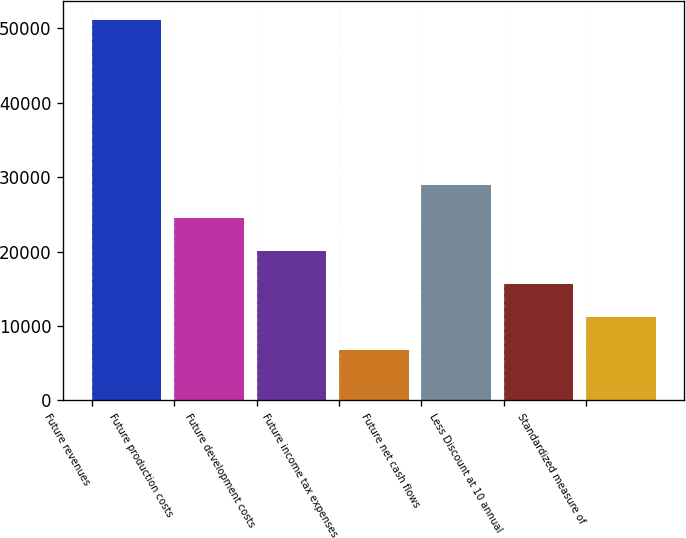Convert chart to OTSL. <chart><loc_0><loc_0><loc_500><loc_500><bar_chart><fcel>Future revenues<fcel>Future production costs<fcel>Future development costs<fcel>Future income tax expenses<fcel>Future net cash flows<fcel>Less Discount at 10 annual<fcel>Standardized measure of<nl><fcel>51054<fcel>24500.4<fcel>20074.8<fcel>6798<fcel>28926<fcel>15649.2<fcel>11223.6<nl></chart> 